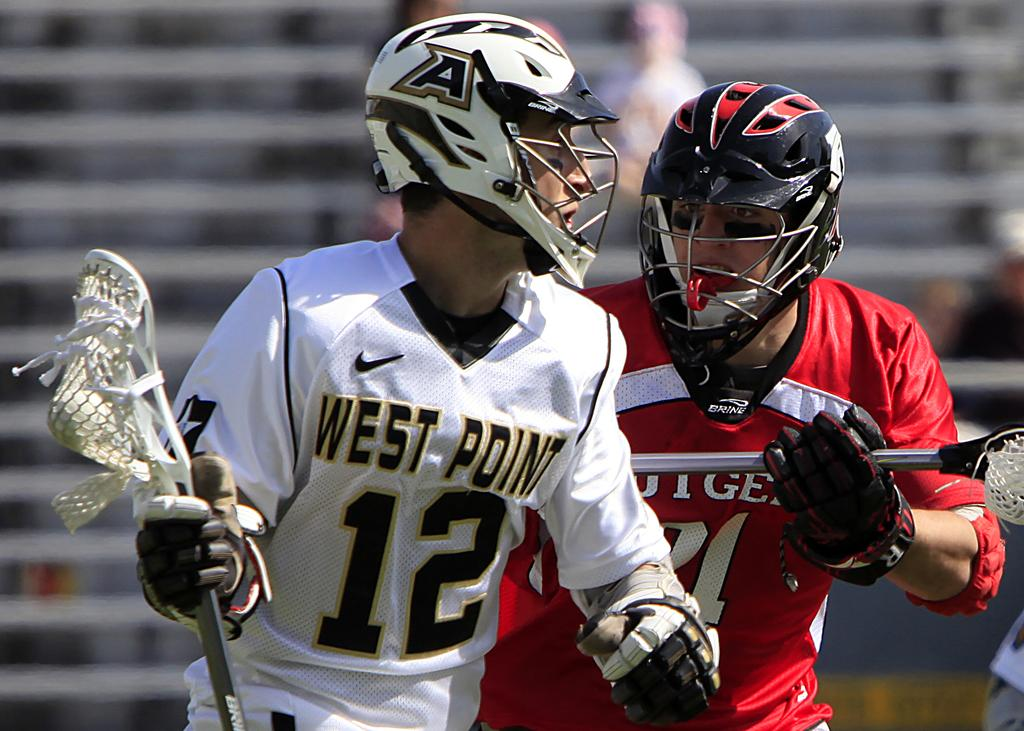How many people are in the image? There are two persons in the image. What activity are the persons engaged in? The two persons are playing a field lacrosse game. What protective gear are the persons wearing? The persons are wearing helmets and gloves. What can be seen in the background of the image? There are stairs visible in the background of the image. What decision did the stranger make before entering the image? There is no stranger present in the image, so it is not possible to determine any decisions they may have made. 